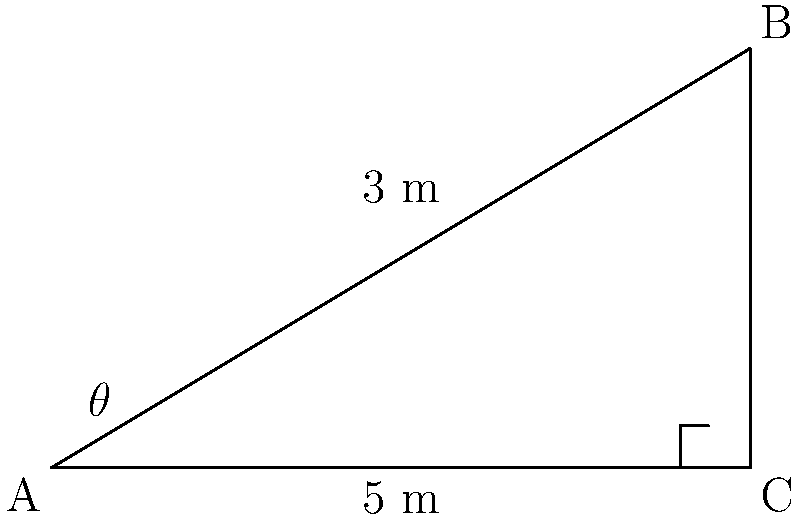In a futuristic sci-fi laboratory, a ramp is designed for transporting sensitive equipment. Given that the ramp's base is 5 meters long and its height is 3 meters, calculate the angle of inclination ($\theta$) of the ramp to the nearest degree. How might this angle affect the movement of the equipment in a low-gravity environment? To solve this problem, we'll use trigonometry to calculate the angle of inclination:

1. We have a right triangle with the following measurements:
   - Base (adjacent side) = 5 meters
   - Height (opposite side) = 3 meters
   - Hypotenuse (the ramp itself) = unknown

2. To find the angle $\theta$, we'll use the tangent function:

   $$\tan(\theta) = \frac{\text{opposite}}{\text{adjacent}} = \frac{3}{5}$$

3. To solve for $\theta$, we take the inverse tangent (arctangent) of both sides:

   $$\theta = \arctan(\frac{3}{5})$$

4. Using a calculator or trigonometric tables:

   $$\theta \approx 30.96^\circ$$

5. Rounding to the nearest degree:

   $$\theta \approx 31^\circ$$

In a low-gravity environment, this angle would affect the movement of equipment in several ways:

- The reduced friction due to lower gravity might cause objects to slide more easily, potentially requiring additional safety measures.
- The energy required to move objects up the ramp would be less than in Earth's gravity, but care must be taken to control the descent.
- The angle is steep enough to provide efficient use of space while still allowing for safe transport of sensitive equipment.
Answer: $31^\circ$ 